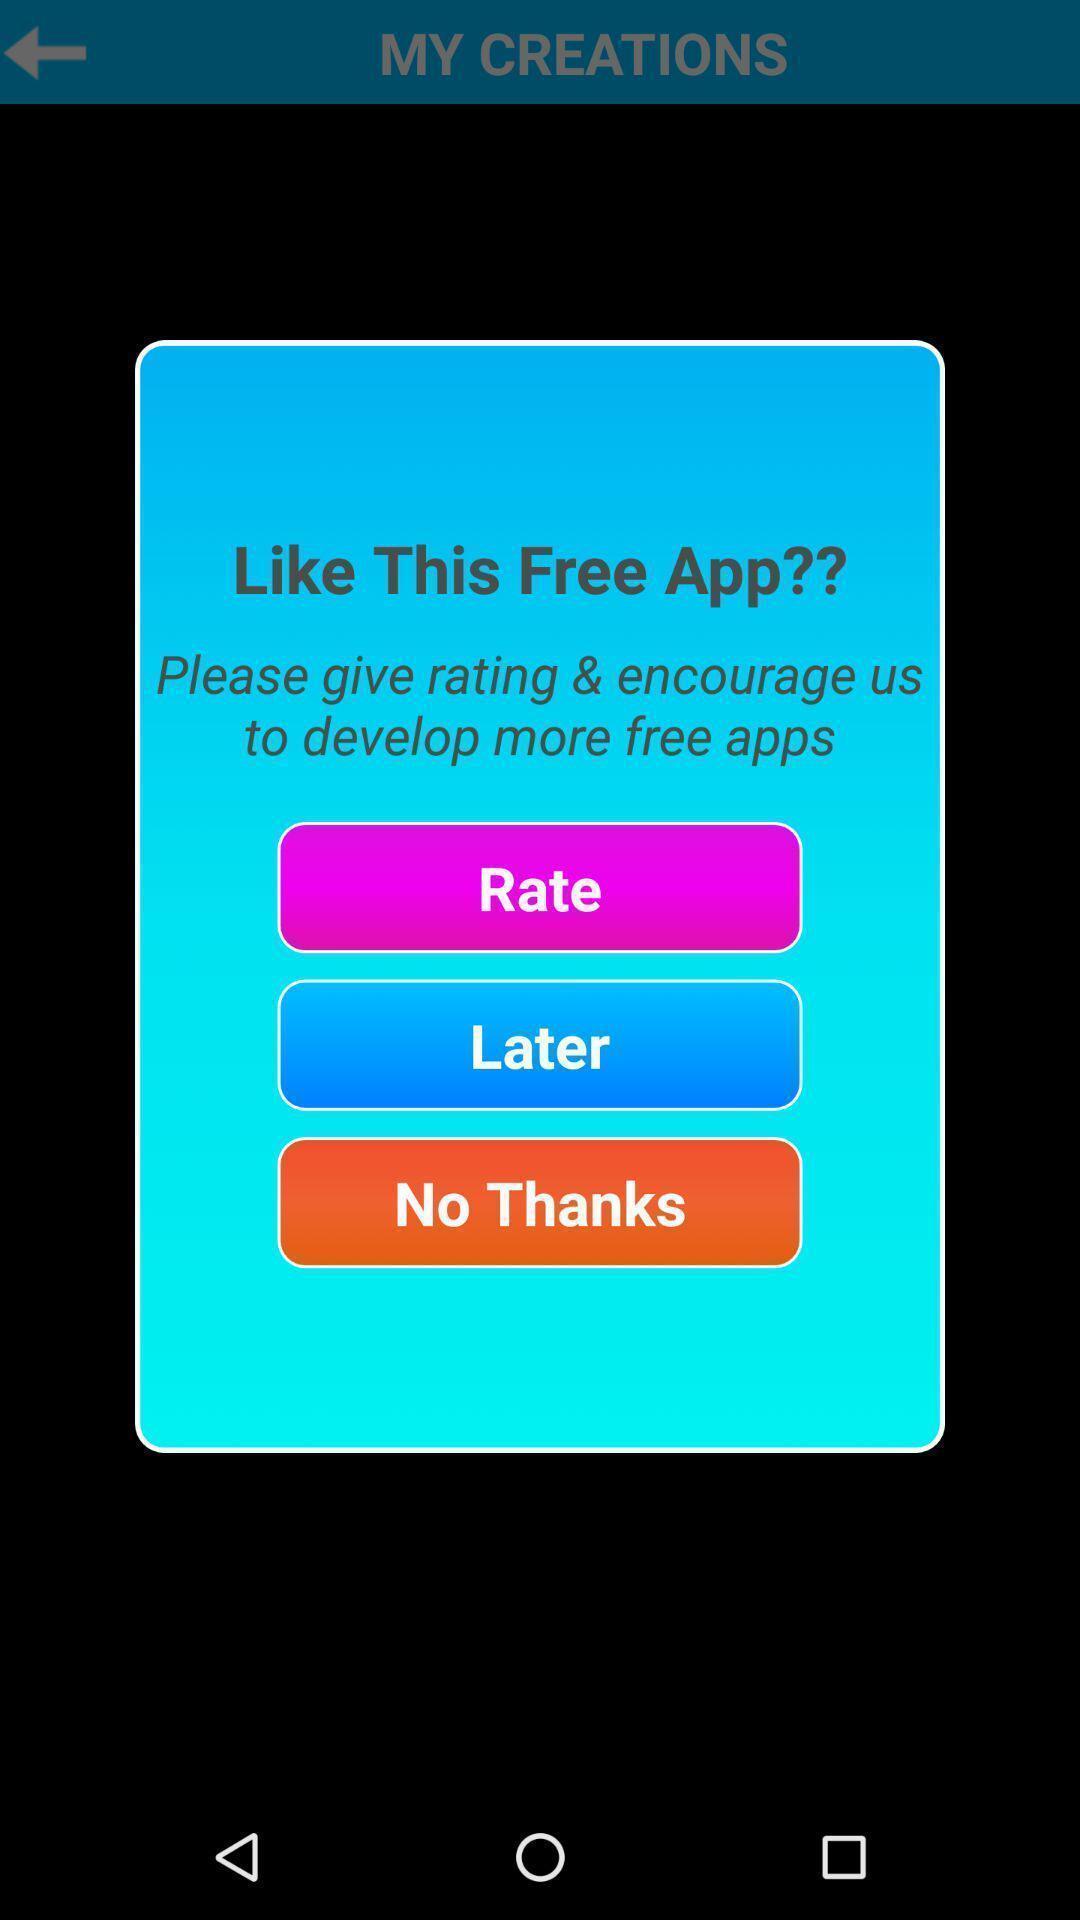Explain the elements present in this screenshot. Popup for feedback. 